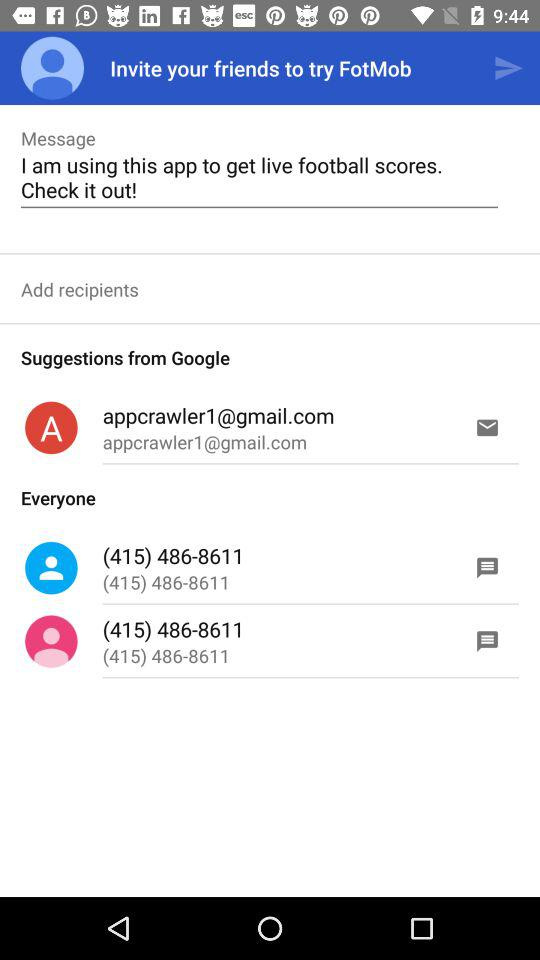What's the contact number? The contact number is (415) 486-8611. 